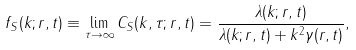<formula> <loc_0><loc_0><loc_500><loc_500>f _ { S } ( k ; r , t ) \equiv \lim _ { \tau \to \infty } C _ { S } ( k , \tau ; r , t ) = \frac { \lambda ( k ; r , t ) } { \lambda ( k ; r , t ) + k ^ { 2 } \gamma ( r , t ) } ,</formula> 